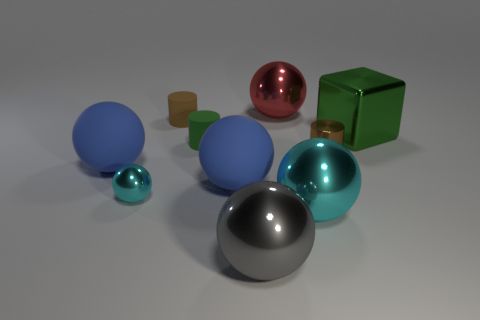Subtract all big cyan balls. How many balls are left? 5 Subtract all blue balls. How many balls are left? 4 Subtract all yellow spheres. Subtract all gray cubes. How many spheres are left? 6 Subtract all blocks. How many objects are left? 9 Add 4 tiny brown rubber things. How many tiny brown rubber things are left? 5 Add 5 green metallic things. How many green metallic things exist? 6 Subtract 0 gray cylinders. How many objects are left? 10 Subtract all blue matte balls. Subtract all big red balls. How many objects are left? 7 